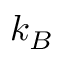Convert formula to latex. <formula><loc_0><loc_0><loc_500><loc_500>k _ { B }</formula> 